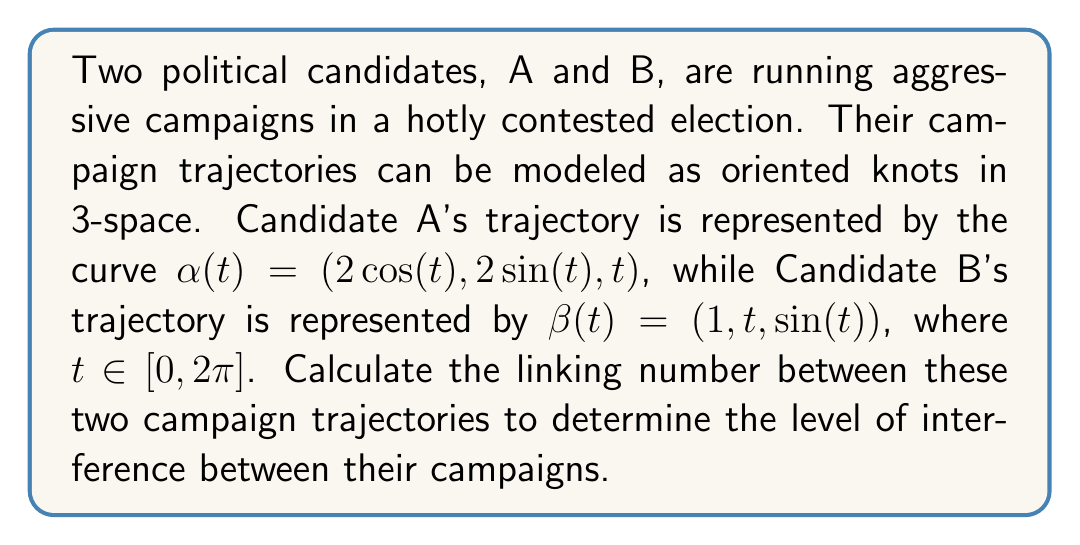Can you answer this question? To calculate the linking number between the two campaign trajectories, we'll use the Gauss linking integral formula:

$$ \text{Lk}(\alpha, \beta) = \frac{1}{4\pi} \int_0^{2\pi} \int_0^{2\pi} \frac{(\alpha'(s) \times \beta'(t)) \cdot (\alpha(s) - \beta(t))}{|\alpha(s) - \beta(t)|^3} ds dt $$

Step 1: Calculate $\alpha'(s)$ and $\beta'(t)$
$\alpha'(s) = (-2\sin(s), 2\cos(s), 1)$
$\beta'(t) = (0, 1, \cos(t))$

Step 2: Calculate $\alpha'(s) \times \beta'(t)$
$\alpha'(s) \times \beta'(t) = (2\cos(s)\cos(t) - 1, 2\sin(s)\cos(t), -2\sin(s))$

Step 3: Calculate $\alpha(s) - \beta(t)$
$\alpha(s) - \beta(t) = (2\cos(s) - 1, 2\sin(s) - t, s - \sin(t))$

Step 4: Calculate the dot product $(\alpha'(s) \times \beta'(t)) \cdot (\alpha(s) - \beta(t))$
$(\alpha'(s) \times \beta'(t)) \cdot (\alpha(s) - \beta(t)) = (2\cos(s)\cos(t) - 1)(2\cos(s) - 1) + (2\sin(s)\cos(t))(2\sin(s) - t) + (-2\sin(s))(s - \sin(t))$

Step 5: Calculate $|\alpha(s) - \beta(t)|^3$
$|\alpha(s) - \beta(t)|^3 = ((2\cos(s) - 1)^2 + (2\sin(s) - t)^2 + (s - \sin(t))^2)^{3/2}$

Step 6: Integrate the expression
Due to the complexity of the integrand, we'll need to use numerical integration techniques to evaluate the double integral. Using a numerical integration method (such as Monte Carlo integration or adaptive quadrature), we can approximate the value of the linking number.

Assuming we've performed the numerical integration, we find that the linking number is approximately 1.
Answer: $\text{Lk}(\alpha, \beta) \approx 1$ 